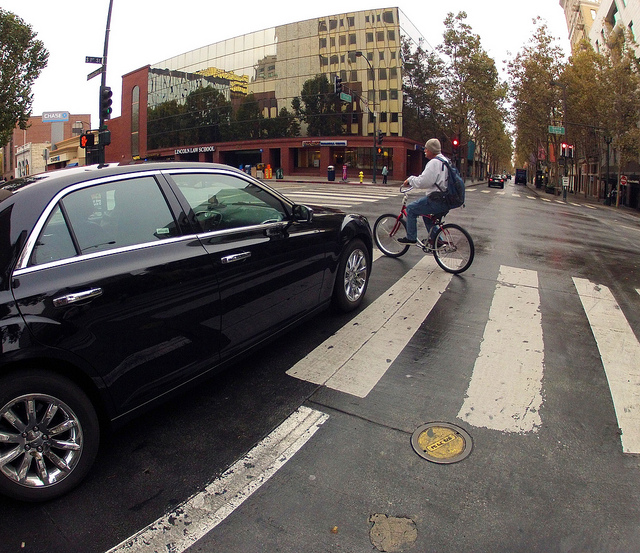<image>Why is the car stopped? I don't know why the car is stopped. It could be due to a cyclist crossing the street or a red light. Why is the car stopped? I don't know why the car is stopped. It can be stopped for various reasons like letting the bike pass, for a red light, or because a man on a bike is in the way. 